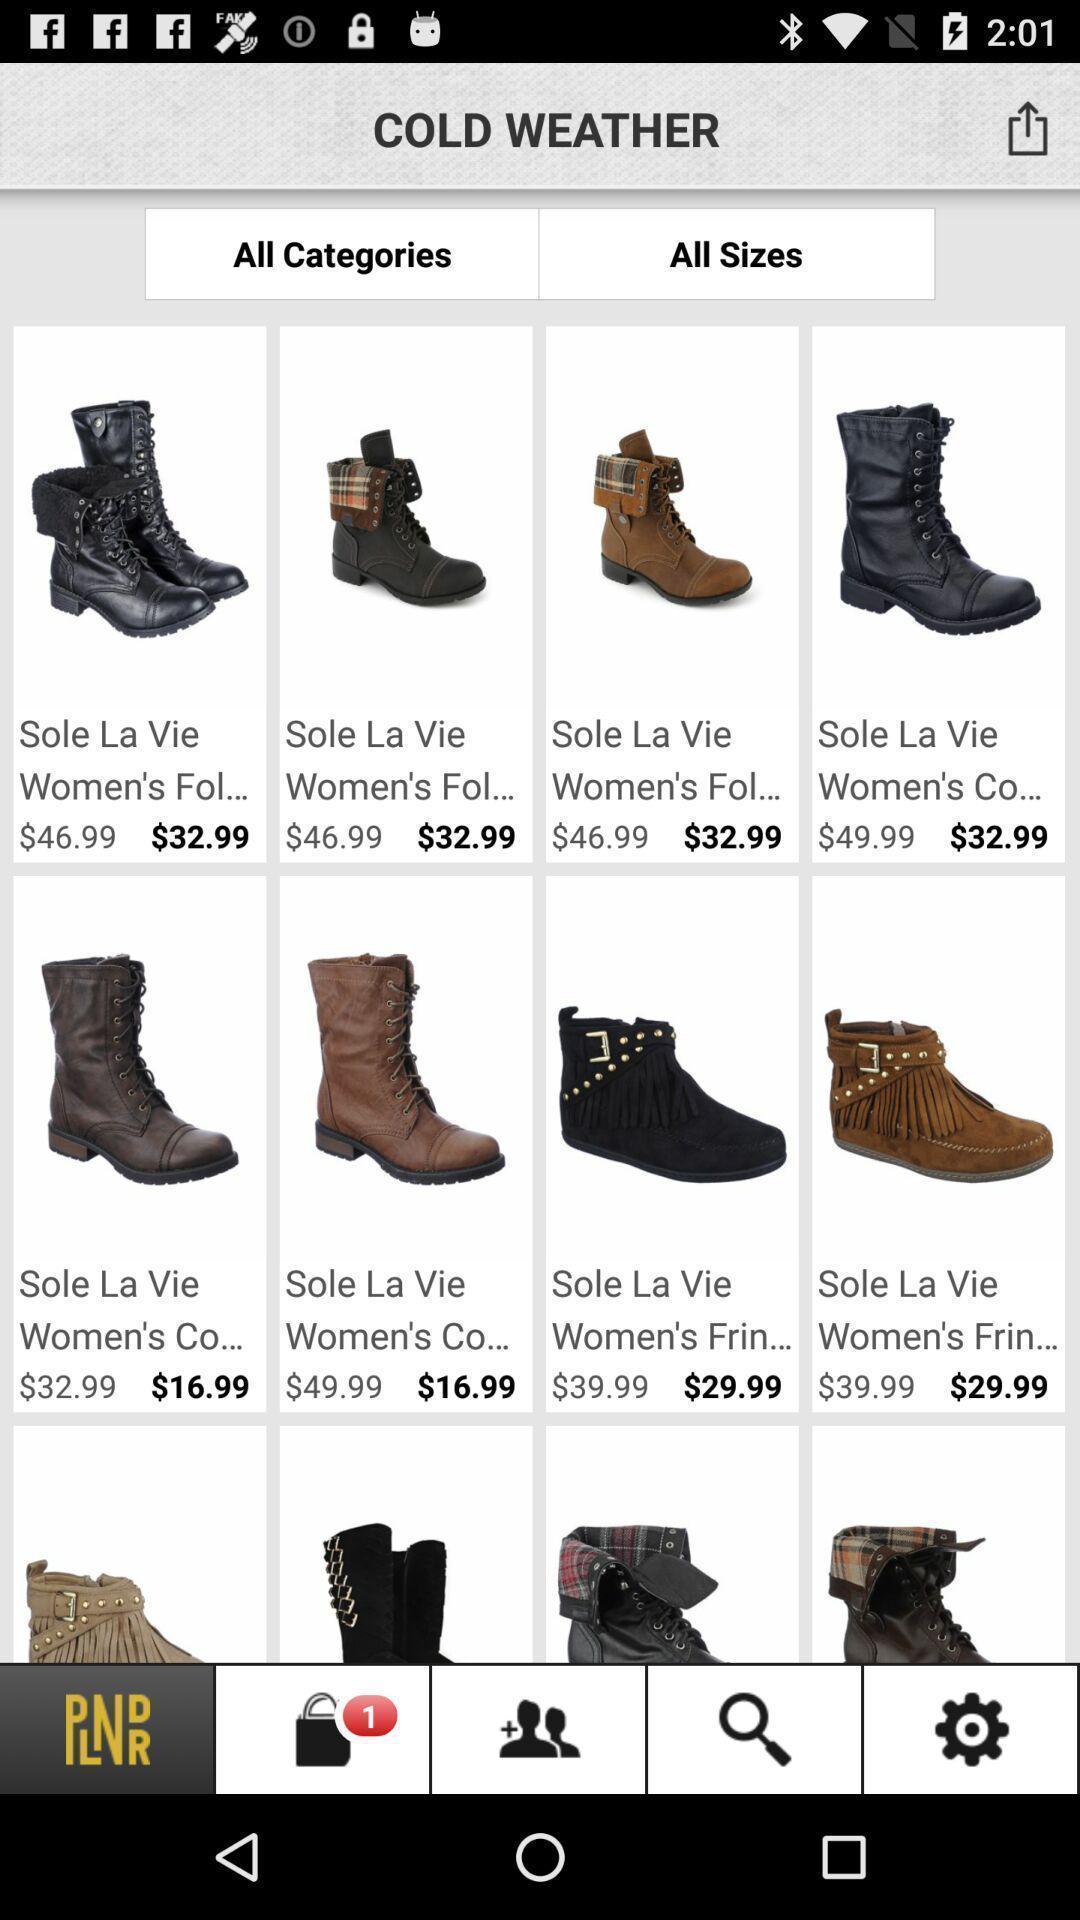Give me a summary of this screen capture. Screen displaying all categories/sizes of boots. 